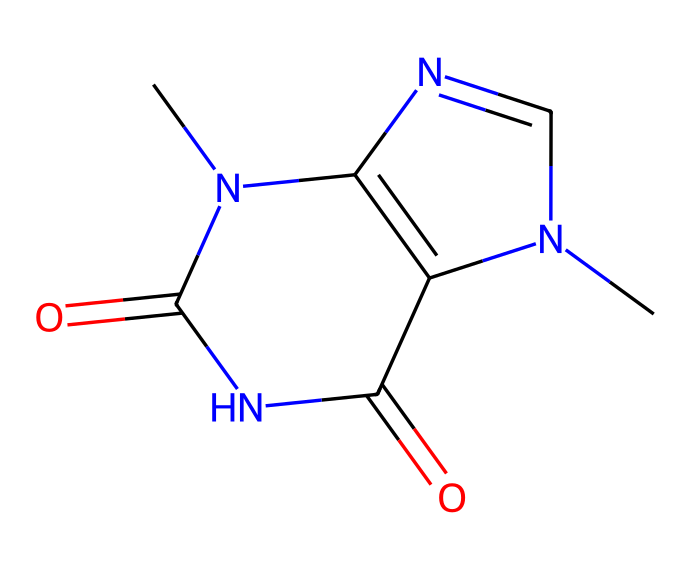What is the molecular formula for theobromine? To determine the molecular formula, we can count the number of each type of atom present in the SMILES representation. The structure contains 7 carbon atoms, 8 hydrogen atoms, 4 nitrogen atoms, and 2 oxygen atoms, leading to a formula of C7H8N4O2.
Answer: C7H8N4O2 How many nitrogen atoms are present in theobromine? By inspecting the chemical structure based on the SMILES, we can identify the number of nitrogen (N) atoms. There are four distinct nitrogen atoms within the structure.
Answer: 4 What type of functional groups are present in theobromine? Theobromine contains amine and carbonyl functional groups among its bonding patterns. The presence of nitrogen in NH groups indicates amine functionality, and the C=O (carbonyl) bonds indicate the presence of two carbonyl groups.
Answer: amine, carbonyl Does theobromine have a ring structure? Analyzing the SMILES indicates that the structure does indeed form a bicyclic compound, which confirms that there are connected rings present in the chemical structure.
Answer: yes What is the total number of rings in theobromine's structure? The structural representation shows two interconnected rings in its structure, which can be counted by closely examining the cyclic portions of the molecule.
Answer: 2 Is theobromine classified as a stimulant? Based on its known properties and its structural features, particularly through its connection to xanthine derivatives, theobromine is classified as a mild stimulant.
Answer: yes 